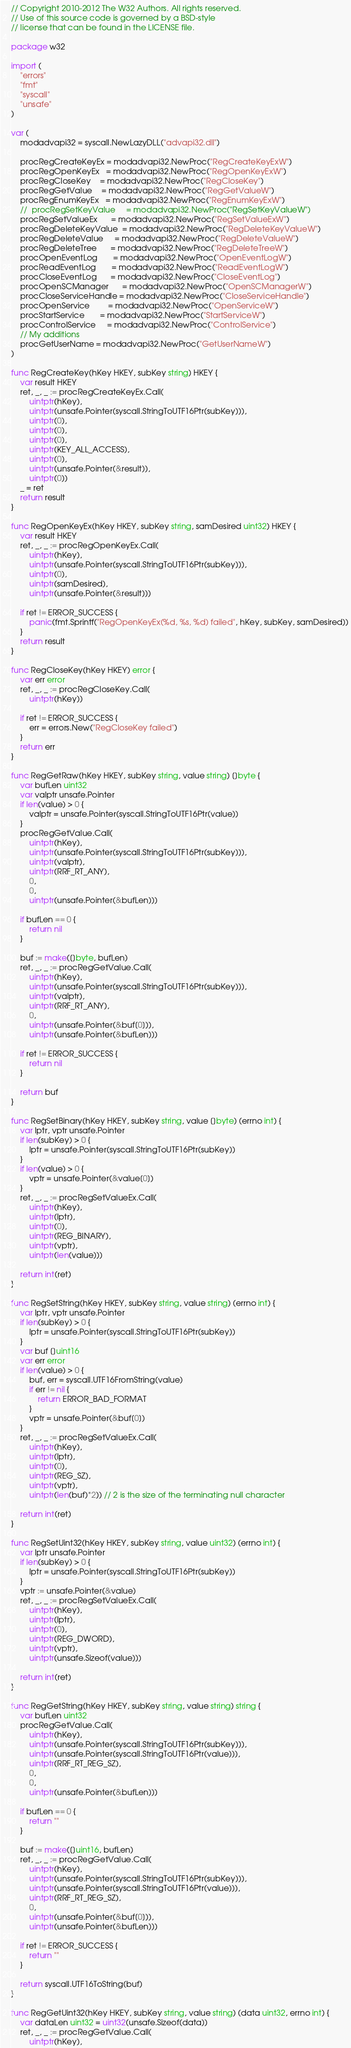<code> <loc_0><loc_0><loc_500><loc_500><_Go_>// Copyright 2010-2012 The W32 Authors. All rights reserved.
// Use of this source code is governed by a BSD-style
// license that can be found in the LICENSE file.

package w32

import (
	"errors"
	"fmt"
	"syscall"
	"unsafe"
)

var (
	modadvapi32 = syscall.NewLazyDLL("advapi32.dll")

	procRegCreateKeyEx = modadvapi32.NewProc("RegCreateKeyExW")
	procRegOpenKeyEx   = modadvapi32.NewProc("RegOpenKeyExW")
	procRegCloseKey    = modadvapi32.NewProc("RegCloseKey")
	procRegGetValue    = modadvapi32.NewProc("RegGetValueW")
	procRegEnumKeyEx   = modadvapi32.NewProc("RegEnumKeyExW")
	//	procRegSetKeyValue     = modadvapi32.NewProc("RegSetKeyValueW")
	procRegSetValueEx      = modadvapi32.NewProc("RegSetValueExW")
	procRegDeleteKeyValue  = modadvapi32.NewProc("RegDeleteKeyValueW")
	procRegDeleteValue     = modadvapi32.NewProc("RegDeleteValueW")
	procRegDeleteTree      = modadvapi32.NewProc("RegDeleteTreeW")
	procOpenEventLog       = modadvapi32.NewProc("OpenEventLogW")
	procReadEventLog       = modadvapi32.NewProc("ReadEventLogW")
	procCloseEventLog      = modadvapi32.NewProc("CloseEventLog")
	procOpenSCManager      = modadvapi32.NewProc("OpenSCManagerW")
	procCloseServiceHandle = modadvapi32.NewProc("CloseServiceHandle")
	procOpenService        = modadvapi32.NewProc("OpenServiceW")
	procStartService       = modadvapi32.NewProc("StartServiceW")
	procControlService     = modadvapi32.NewProc("ControlService")
	// My additions
	procGetUserName = modadvapi32.NewProc("GetUserNameW")
)

func RegCreateKey(hKey HKEY, subKey string) HKEY {
	var result HKEY
	ret, _, _ := procRegCreateKeyEx.Call(
		uintptr(hKey),
		uintptr(unsafe.Pointer(syscall.StringToUTF16Ptr(subKey))),
		uintptr(0),
		uintptr(0),
		uintptr(0),
		uintptr(KEY_ALL_ACCESS),
		uintptr(0),
		uintptr(unsafe.Pointer(&result)),
		uintptr(0))
	_ = ret
	return result
}

func RegOpenKeyEx(hKey HKEY, subKey string, samDesired uint32) HKEY {
	var result HKEY
	ret, _, _ := procRegOpenKeyEx.Call(
		uintptr(hKey),
		uintptr(unsafe.Pointer(syscall.StringToUTF16Ptr(subKey))),
		uintptr(0),
		uintptr(samDesired),
		uintptr(unsafe.Pointer(&result)))

	if ret != ERROR_SUCCESS {
		panic(fmt.Sprintf("RegOpenKeyEx(%d, %s, %d) failed", hKey, subKey, samDesired))
	}
	return result
}

func RegCloseKey(hKey HKEY) error {
	var err error
	ret, _, _ := procRegCloseKey.Call(
		uintptr(hKey))

	if ret != ERROR_SUCCESS {
		err = errors.New("RegCloseKey failed")
	}
	return err
}

func RegGetRaw(hKey HKEY, subKey string, value string) []byte {
	var bufLen uint32
	var valptr unsafe.Pointer
	if len(value) > 0 {
		valptr = unsafe.Pointer(syscall.StringToUTF16Ptr(value))
	}
	procRegGetValue.Call(
		uintptr(hKey),
		uintptr(unsafe.Pointer(syscall.StringToUTF16Ptr(subKey))),
		uintptr(valptr),
		uintptr(RRF_RT_ANY),
		0,
		0,
		uintptr(unsafe.Pointer(&bufLen)))

	if bufLen == 0 {
		return nil
	}

	buf := make([]byte, bufLen)
	ret, _, _ := procRegGetValue.Call(
		uintptr(hKey),
		uintptr(unsafe.Pointer(syscall.StringToUTF16Ptr(subKey))),
		uintptr(valptr),
		uintptr(RRF_RT_ANY),
		0,
		uintptr(unsafe.Pointer(&buf[0])),
		uintptr(unsafe.Pointer(&bufLen)))

	if ret != ERROR_SUCCESS {
		return nil
	}

	return buf
}

func RegSetBinary(hKey HKEY, subKey string, value []byte) (errno int) {
	var lptr, vptr unsafe.Pointer
	if len(subKey) > 0 {
		lptr = unsafe.Pointer(syscall.StringToUTF16Ptr(subKey))
	}
	if len(value) > 0 {
		vptr = unsafe.Pointer(&value[0])
	}
	ret, _, _ := procRegSetValueEx.Call(
		uintptr(hKey),
		uintptr(lptr),
		uintptr(0),
		uintptr(REG_BINARY),
		uintptr(vptr),
		uintptr(len(value)))

	return int(ret)
}

func RegSetString(hKey HKEY, subKey string, value string) (errno int) {
	var lptr, vptr unsafe.Pointer
	if len(subKey) > 0 {
		lptr = unsafe.Pointer(syscall.StringToUTF16Ptr(subKey))
	}
	var buf []uint16
	var err error
	if len(value) > 0 {
		buf, err = syscall.UTF16FromString(value)
		if err != nil {
			return ERROR_BAD_FORMAT
		}
		vptr = unsafe.Pointer(&buf[0])
	}
	ret, _, _ := procRegSetValueEx.Call(
		uintptr(hKey),
		uintptr(lptr),
		uintptr(0),
		uintptr(REG_SZ),
		uintptr(vptr),
		uintptr(len(buf)*2)) // 2 is the size of the terminating null character

	return int(ret)
}

func RegSetUint32(hKey HKEY, subKey string, value uint32) (errno int) {
	var lptr unsafe.Pointer
	if len(subKey) > 0 {
		lptr = unsafe.Pointer(syscall.StringToUTF16Ptr(subKey))
	}
	vptr := unsafe.Pointer(&value)
	ret, _, _ := procRegSetValueEx.Call(
		uintptr(hKey),
		uintptr(lptr),
		uintptr(0),
		uintptr(REG_DWORD),
		uintptr(vptr),
		uintptr(unsafe.Sizeof(value)))

	return int(ret)
}

func RegGetString(hKey HKEY, subKey string, value string) string {
	var bufLen uint32
	procRegGetValue.Call(
		uintptr(hKey),
		uintptr(unsafe.Pointer(syscall.StringToUTF16Ptr(subKey))),
		uintptr(unsafe.Pointer(syscall.StringToUTF16Ptr(value))),
		uintptr(RRF_RT_REG_SZ),
		0,
		0,
		uintptr(unsafe.Pointer(&bufLen)))

	if bufLen == 0 {
		return ""
	}

	buf := make([]uint16, bufLen)
	ret, _, _ := procRegGetValue.Call(
		uintptr(hKey),
		uintptr(unsafe.Pointer(syscall.StringToUTF16Ptr(subKey))),
		uintptr(unsafe.Pointer(syscall.StringToUTF16Ptr(value))),
		uintptr(RRF_RT_REG_SZ),
		0,
		uintptr(unsafe.Pointer(&buf[0])),
		uintptr(unsafe.Pointer(&bufLen)))

	if ret != ERROR_SUCCESS {
		return ""
	}

	return syscall.UTF16ToString(buf)
}

func RegGetUint32(hKey HKEY, subKey string, value string) (data uint32, errno int) {
	var dataLen uint32 = uint32(unsafe.Sizeof(data))
	ret, _, _ := procRegGetValue.Call(
		uintptr(hKey),</code> 